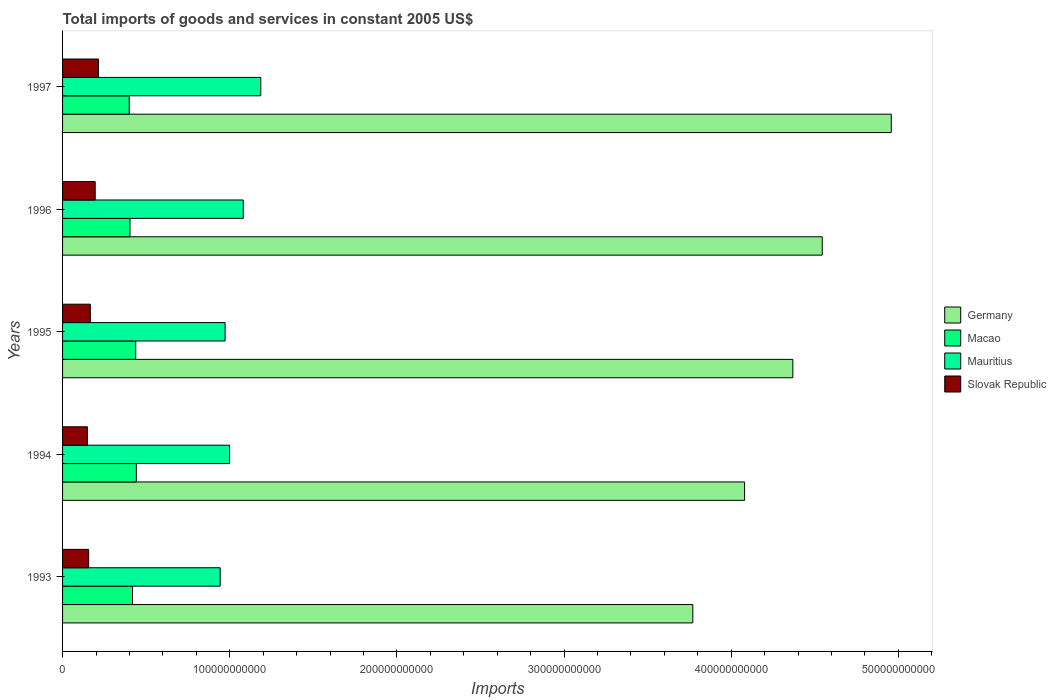How many different coloured bars are there?
Ensure brevity in your answer.  4. Are the number of bars per tick equal to the number of legend labels?
Provide a succinct answer. Yes. Are the number of bars on each tick of the Y-axis equal?
Give a very brief answer. Yes. How many bars are there on the 4th tick from the bottom?
Keep it short and to the point. 4. What is the total imports of goods and services in Germany in 1996?
Your answer should be compact. 4.54e+11. Across all years, what is the maximum total imports of goods and services in Slovak Republic?
Keep it short and to the point. 2.15e+1. Across all years, what is the minimum total imports of goods and services in Slovak Republic?
Offer a terse response. 1.49e+1. In which year was the total imports of goods and services in Mauritius maximum?
Your answer should be very brief. 1997. What is the total total imports of goods and services in Macao in the graph?
Offer a terse response. 2.10e+11. What is the difference between the total imports of goods and services in Slovak Republic in 1994 and that in 1995?
Keep it short and to the point. -1.73e+09. What is the difference between the total imports of goods and services in Macao in 1994 and the total imports of goods and services in Germany in 1997?
Provide a short and direct response. -4.52e+11. What is the average total imports of goods and services in Macao per year?
Ensure brevity in your answer.  4.20e+1. In the year 1994, what is the difference between the total imports of goods and services in Germany and total imports of goods and services in Macao?
Provide a succinct answer. 3.64e+11. In how many years, is the total imports of goods and services in Slovak Republic greater than 320000000000 US$?
Make the answer very short. 0. What is the ratio of the total imports of goods and services in Slovak Republic in 1995 to that in 1996?
Your answer should be very brief. 0.85. What is the difference between the highest and the second highest total imports of goods and services in Mauritius?
Make the answer very short. 1.05e+1. What is the difference between the highest and the lowest total imports of goods and services in Macao?
Keep it short and to the point. 4.26e+09. In how many years, is the total imports of goods and services in Germany greater than the average total imports of goods and services in Germany taken over all years?
Make the answer very short. 3. Is the sum of the total imports of goods and services in Mauritius in 1995 and 1997 greater than the maximum total imports of goods and services in Macao across all years?
Your answer should be very brief. Yes. What does the 2nd bar from the top in 1993 represents?
Keep it short and to the point. Mauritius. What does the 2nd bar from the bottom in 1996 represents?
Offer a very short reply. Macao. Is it the case that in every year, the sum of the total imports of goods and services in Macao and total imports of goods and services in Germany is greater than the total imports of goods and services in Slovak Republic?
Give a very brief answer. Yes. What is the difference between two consecutive major ticks on the X-axis?
Make the answer very short. 1.00e+11. Are the values on the major ticks of X-axis written in scientific E-notation?
Keep it short and to the point. No. Does the graph contain any zero values?
Offer a terse response. No. Where does the legend appear in the graph?
Your answer should be very brief. Center right. How many legend labels are there?
Provide a short and direct response. 4. What is the title of the graph?
Provide a short and direct response. Total imports of goods and services in constant 2005 US$. What is the label or title of the X-axis?
Offer a terse response. Imports. What is the label or title of the Y-axis?
Offer a terse response. Years. What is the Imports of Germany in 1993?
Provide a succinct answer. 3.77e+11. What is the Imports in Macao in 1993?
Ensure brevity in your answer.  4.18e+1. What is the Imports in Mauritius in 1993?
Provide a succinct answer. 9.43e+1. What is the Imports in Slovak Republic in 1993?
Make the answer very short. 1.56e+1. What is the Imports of Germany in 1994?
Your answer should be compact. 4.08e+11. What is the Imports of Macao in 1994?
Your answer should be very brief. 4.41e+1. What is the Imports in Mauritius in 1994?
Your answer should be compact. 9.99e+1. What is the Imports of Slovak Republic in 1994?
Offer a very short reply. 1.49e+1. What is the Imports of Germany in 1995?
Ensure brevity in your answer.  4.37e+11. What is the Imports in Macao in 1995?
Provide a succinct answer. 4.38e+1. What is the Imports in Mauritius in 1995?
Your response must be concise. 9.72e+1. What is the Imports in Slovak Republic in 1995?
Ensure brevity in your answer.  1.66e+1. What is the Imports in Germany in 1996?
Offer a terse response. 4.54e+11. What is the Imports of Macao in 1996?
Your answer should be compact. 4.03e+1. What is the Imports of Mauritius in 1996?
Keep it short and to the point. 1.08e+11. What is the Imports in Slovak Republic in 1996?
Ensure brevity in your answer.  1.95e+1. What is the Imports of Germany in 1997?
Your answer should be very brief. 4.96e+11. What is the Imports of Macao in 1997?
Give a very brief answer. 3.99e+1. What is the Imports of Mauritius in 1997?
Keep it short and to the point. 1.19e+11. What is the Imports in Slovak Republic in 1997?
Your answer should be very brief. 2.15e+1. Across all years, what is the maximum Imports of Germany?
Your response must be concise. 4.96e+11. Across all years, what is the maximum Imports in Macao?
Keep it short and to the point. 4.41e+1. Across all years, what is the maximum Imports of Mauritius?
Provide a succinct answer. 1.19e+11. Across all years, what is the maximum Imports in Slovak Republic?
Provide a succinct answer. 2.15e+1. Across all years, what is the minimum Imports of Germany?
Provide a short and direct response. 3.77e+11. Across all years, what is the minimum Imports of Macao?
Make the answer very short. 3.99e+1. Across all years, what is the minimum Imports of Mauritius?
Keep it short and to the point. 9.43e+1. Across all years, what is the minimum Imports in Slovak Republic?
Your answer should be very brief. 1.49e+1. What is the total Imports in Germany in the graph?
Keep it short and to the point. 2.17e+12. What is the total Imports in Macao in the graph?
Make the answer very short. 2.10e+11. What is the total Imports of Mauritius in the graph?
Ensure brevity in your answer.  5.18e+11. What is the total Imports of Slovak Republic in the graph?
Your answer should be very brief. 8.81e+1. What is the difference between the Imports in Germany in 1993 and that in 1994?
Offer a terse response. -3.10e+1. What is the difference between the Imports of Macao in 1993 and that in 1994?
Make the answer very short. -2.30e+09. What is the difference between the Imports in Mauritius in 1993 and that in 1994?
Give a very brief answer. -5.61e+09. What is the difference between the Imports in Slovak Republic in 1993 and that in 1994?
Offer a terse response. 7.39e+08. What is the difference between the Imports in Germany in 1993 and that in 1995?
Keep it short and to the point. -5.98e+1. What is the difference between the Imports in Macao in 1993 and that in 1995?
Your answer should be very brief. -1.95e+09. What is the difference between the Imports in Mauritius in 1993 and that in 1995?
Offer a very short reply. -2.93e+09. What is the difference between the Imports in Slovak Republic in 1993 and that in 1995?
Give a very brief answer. -9.92e+08. What is the difference between the Imports in Germany in 1993 and that in 1996?
Your answer should be compact. -7.74e+1. What is the difference between the Imports in Macao in 1993 and that in 1996?
Offer a very short reply. 1.51e+09. What is the difference between the Imports of Mauritius in 1993 and that in 1996?
Offer a terse response. -1.38e+1. What is the difference between the Imports in Slovak Republic in 1993 and that in 1996?
Your response must be concise. -3.91e+09. What is the difference between the Imports in Germany in 1993 and that in 1997?
Your answer should be very brief. -1.19e+11. What is the difference between the Imports of Macao in 1993 and that in 1997?
Give a very brief answer. 1.95e+09. What is the difference between the Imports in Mauritius in 1993 and that in 1997?
Provide a succinct answer. -2.43e+1. What is the difference between the Imports of Slovak Republic in 1993 and that in 1997?
Your answer should be very brief. -5.89e+09. What is the difference between the Imports of Germany in 1994 and that in 1995?
Provide a short and direct response. -2.89e+1. What is the difference between the Imports of Macao in 1994 and that in 1995?
Provide a short and direct response. 3.53e+08. What is the difference between the Imports of Mauritius in 1994 and that in 1995?
Keep it short and to the point. 2.69e+09. What is the difference between the Imports in Slovak Republic in 1994 and that in 1995?
Your answer should be compact. -1.73e+09. What is the difference between the Imports of Germany in 1994 and that in 1996?
Your answer should be very brief. -4.65e+1. What is the difference between the Imports of Macao in 1994 and that in 1996?
Offer a terse response. 3.81e+09. What is the difference between the Imports of Mauritius in 1994 and that in 1996?
Provide a short and direct response. -8.19e+09. What is the difference between the Imports in Slovak Republic in 1994 and that in 1996?
Your answer should be compact. -4.65e+09. What is the difference between the Imports in Germany in 1994 and that in 1997?
Your response must be concise. -8.78e+1. What is the difference between the Imports of Macao in 1994 and that in 1997?
Your response must be concise. 4.26e+09. What is the difference between the Imports in Mauritius in 1994 and that in 1997?
Your answer should be very brief. -1.87e+1. What is the difference between the Imports of Slovak Republic in 1994 and that in 1997?
Keep it short and to the point. -6.63e+09. What is the difference between the Imports of Germany in 1995 and that in 1996?
Make the answer very short. -1.76e+1. What is the difference between the Imports in Macao in 1995 and that in 1996?
Your answer should be very brief. 3.46e+09. What is the difference between the Imports in Mauritius in 1995 and that in 1996?
Offer a very short reply. -1.09e+1. What is the difference between the Imports of Slovak Republic in 1995 and that in 1996?
Provide a short and direct response. -2.92e+09. What is the difference between the Imports in Germany in 1995 and that in 1997?
Your answer should be very brief. -5.89e+1. What is the difference between the Imports in Macao in 1995 and that in 1997?
Ensure brevity in your answer.  3.90e+09. What is the difference between the Imports in Mauritius in 1995 and that in 1997?
Your answer should be very brief. -2.14e+1. What is the difference between the Imports in Slovak Republic in 1995 and that in 1997?
Offer a very short reply. -4.90e+09. What is the difference between the Imports of Germany in 1996 and that in 1997?
Give a very brief answer. -4.13e+1. What is the difference between the Imports in Macao in 1996 and that in 1997?
Keep it short and to the point. 4.44e+08. What is the difference between the Imports of Mauritius in 1996 and that in 1997?
Ensure brevity in your answer.  -1.05e+1. What is the difference between the Imports of Slovak Republic in 1996 and that in 1997?
Your answer should be very brief. -1.98e+09. What is the difference between the Imports of Germany in 1993 and the Imports of Macao in 1994?
Keep it short and to the point. 3.33e+11. What is the difference between the Imports of Germany in 1993 and the Imports of Mauritius in 1994?
Your response must be concise. 2.77e+11. What is the difference between the Imports of Germany in 1993 and the Imports of Slovak Republic in 1994?
Your answer should be compact. 3.62e+11. What is the difference between the Imports of Macao in 1993 and the Imports of Mauritius in 1994?
Ensure brevity in your answer.  -5.81e+1. What is the difference between the Imports of Macao in 1993 and the Imports of Slovak Republic in 1994?
Provide a succinct answer. 2.70e+1. What is the difference between the Imports in Mauritius in 1993 and the Imports in Slovak Republic in 1994?
Keep it short and to the point. 7.94e+1. What is the difference between the Imports of Germany in 1993 and the Imports of Macao in 1995?
Offer a very short reply. 3.33e+11. What is the difference between the Imports of Germany in 1993 and the Imports of Mauritius in 1995?
Your answer should be very brief. 2.80e+11. What is the difference between the Imports of Germany in 1993 and the Imports of Slovak Republic in 1995?
Ensure brevity in your answer.  3.60e+11. What is the difference between the Imports of Macao in 1993 and the Imports of Mauritius in 1995?
Give a very brief answer. -5.54e+1. What is the difference between the Imports in Macao in 1993 and the Imports in Slovak Republic in 1995?
Provide a short and direct response. 2.52e+1. What is the difference between the Imports of Mauritius in 1993 and the Imports of Slovak Republic in 1995?
Your answer should be very brief. 7.77e+1. What is the difference between the Imports in Germany in 1993 and the Imports in Macao in 1996?
Ensure brevity in your answer.  3.37e+11. What is the difference between the Imports of Germany in 1993 and the Imports of Mauritius in 1996?
Provide a succinct answer. 2.69e+11. What is the difference between the Imports in Germany in 1993 and the Imports in Slovak Republic in 1996?
Ensure brevity in your answer.  3.58e+11. What is the difference between the Imports in Macao in 1993 and the Imports in Mauritius in 1996?
Offer a terse response. -6.63e+1. What is the difference between the Imports of Macao in 1993 and the Imports of Slovak Republic in 1996?
Your answer should be compact. 2.23e+1. What is the difference between the Imports of Mauritius in 1993 and the Imports of Slovak Republic in 1996?
Provide a succinct answer. 7.48e+1. What is the difference between the Imports in Germany in 1993 and the Imports in Macao in 1997?
Give a very brief answer. 3.37e+11. What is the difference between the Imports in Germany in 1993 and the Imports in Mauritius in 1997?
Your answer should be very brief. 2.58e+11. What is the difference between the Imports in Germany in 1993 and the Imports in Slovak Republic in 1997?
Give a very brief answer. 3.56e+11. What is the difference between the Imports of Macao in 1993 and the Imports of Mauritius in 1997?
Give a very brief answer. -7.68e+1. What is the difference between the Imports in Macao in 1993 and the Imports in Slovak Republic in 1997?
Make the answer very short. 2.03e+1. What is the difference between the Imports in Mauritius in 1993 and the Imports in Slovak Republic in 1997?
Your answer should be very brief. 7.28e+1. What is the difference between the Imports of Germany in 1994 and the Imports of Macao in 1995?
Provide a succinct answer. 3.64e+11. What is the difference between the Imports in Germany in 1994 and the Imports in Mauritius in 1995?
Ensure brevity in your answer.  3.11e+11. What is the difference between the Imports in Germany in 1994 and the Imports in Slovak Republic in 1995?
Offer a very short reply. 3.91e+11. What is the difference between the Imports in Macao in 1994 and the Imports in Mauritius in 1995?
Ensure brevity in your answer.  -5.31e+1. What is the difference between the Imports in Macao in 1994 and the Imports in Slovak Republic in 1995?
Offer a very short reply. 2.75e+1. What is the difference between the Imports of Mauritius in 1994 and the Imports of Slovak Republic in 1995?
Provide a short and direct response. 8.33e+1. What is the difference between the Imports in Germany in 1994 and the Imports in Macao in 1996?
Offer a very short reply. 3.68e+11. What is the difference between the Imports in Germany in 1994 and the Imports in Mauritius in 1996?
Your answer should be very brief. 3.00e+11. What is the difference between the Imports of Germany in 1994 and the Imports of Slovak Republic in 1996?
Your answer should be compact. 3.88e+11. What is the difference between the Imports of Macao in 1994 and the Imports of Mauritius in 1996?
Your response must be concise. -6.40e+1. What is the difference between the Imports of Macao in 1994 and the Imports of Slovak Republic in 1996?
Keep it short and to the point. 2.46e+1. What is the difference between the Imports of Mauritius in 1994 and the Imports of Slovak Republic in 1996?
Your response must be concise. 8.04e+1. What is the difference between the Imports in Germany in 1994 and the Imports in Macao in 1997?
Provide a succinct answer. 3.68e+11. What is the difference between the Imports of Germany in 1994 and the Imports of Mauritius in 1997?
Offer a terse response. 2.89e+11. What is the difference between the Imports of Germany in 1994 and the Imports of Slovak Republic in 1997?
Provide a short and direct response. 3.87e+11. What is the difference between the Imports in Macao in 1994 and the Imports in Mauritius in 1997?
Make the answer very short. -7.45e+1. What is the difference between the Imports of Macao in 1994 and the Imports of Slovak Republic in 1997?
Ensure brevity in your answer.  2.26e+1. What is the difference between the Imports of Mauritius in 1994 and the Imports of Slovak Republic in 1997?
Your answer should be compact. 7.84e+1. What is the difference between the Imports in Germany in 1995 and the Imports in Macao in 1996?
Offer a very short reply. 3.97e+11. What is the difference between the Imports in Germany in 1995 and the Imports in Mauritius in 1996?
Your answer should be compact. 3.29e+11. What is the difference between the Imports in Germany in 1995 and the Imports in Slovak Republic in 1996?
Provide a short and direct response. 4.17e+11. What is the difference between the Imports in Macao in 1995 and the Imports in Mauritius in 1996?
Provide a succinct answer. -6.43e+1. What is the difference between the Imports in Macao in 1995 and the Imports in Slovak Republic in 1996?
Provide a succinct answer. 2.43e+1. What is the difference between the Imports of Mauritius in 1995 and the Imports of Slovak Republic in 1996?
Your answer should be very brief. 7.77e+1. What is the difference between the Imports of Germany in 1995 and the Imports of Macao in 1997?
Make the answer very short. 3.97e+11. What is the difference between the Imports of Germany in 1995 and the Imports of Mauritius in 1997?
Give a very brief answer. 3.18e+11. What is the difference between the Imports of Germany in 1995 and the Imports of Slovak Republic in 1997?
Offer a very short reply. 4.15e+11. What is the difference between the Imports in Macao in 1995 and the Imports in Mauritius in 1997?
Provide a short and direct response. -7.48e+1. What is the difference between the Imports of Macao in 1995 and the Imports of Slovak Republic in 1997?
Your answer should be compact. 2.23e+1. What is the difference between the Imports in Mauritius in 1995 and the Imports in Slovak Republic in 1997?
Give a very brief answer. 7.57e+1. What is the difference between the Imports of Germany in 1996 and the Imports of Macao in 1997?
Provide a short and direct response. 4.15e+11. What is the difference between the Imports of Germany in 1996 and the Imports of Mauritius in 1997?
Offer a terse response. 3.36e+11. What is the difference between the Imports in Germany in 1996 and the Imports in Slovak Republic in 1997?
Your response must be concise. 4.33e+11. What is the difference between the Imports of Macao in 1996 and the Imports of Mauritius in 1997?
Your answer should be compact. -7.83e+1. What is the difference between the Imports in Macao in 1996 and the Imports in Slovak Republic in 1997?
Your answer should be compact. 1.88e+1. What is the difference between the Imports in Mauritius in 1996 and the Imports in Slovak Republic in 1997?
Provide a succinct answer. 8.66e+1. What is the average Imports in Germany per year?
Keep it short and to the point. 4.34e+11. What is the average Imports of Macao per year?
Provide a succinct answer. 4.20e+1. What is the average Imports of Mauritius per year?
Offer a terse response. 1.04e+11. What is the average Imports of Slovak Republic per year?
Offer a very short reply. 1.76e+1. In the year 1993, what is the difference between the Imports in Germany and Imports in Macao?
Your response must be concise. 3.35e+11. In the year 1993, what is the difference between the Imports in Germany and Imports in Mauritius?
Your answer should be compact. 2.83e+11. In the year 1993, what is the difference between the Imports in Germany and Imports in Slovak Republic?
Provide a succinct answer. 3.61e+11. In the year 1993, what is the difference between the Imports in Macao and Imports in Mauritius?
Provide a succinct answer. -5.25e+1. In the year 1993, what is the difference between the Imports in Macao and Imports in Slovak Republic?
Provide a short and direct response. 2.62e+1. In the year 1993, what is the difference between the Imports in Mauritius and Imports in Slovak Republic?
Give a very brief answer. 7.87e+1. In the year 1994, what is the difference between the Imports of Germany and Imports of Macao?
Keep it short and to the point. 3.64e+11. In the year 1994, what is the difference between the Imports of Germany and Imports of Mauritius?
Ensure brevity in your answer.  3.08e+11. In the year 1994, what is the difference between the Imports in Germany and Imports in Slovak Republic?
Provide a short and direct response. 3.93e+11. In the year 1994, what is the difference between the Imports in Macao and Imports in Mauritius?
Keep it short and to the point. -5.58e+1. In the year 1994, what is the difference between the Imports in Macao and Imports in Slovak Republic?
Keep it short and to the point. 2.93e+1. In the year 1994, what is the difference between the Imports in Mauritius and Imports in Slovak Republic?
Make the answer very short. 8.50e+1. In the year 1995, what is the difference between the Imports of Germany and Imports of Macao?
Your answer should be compact. 3.93e+11. In the year 1995, what is the difference between the Imports of Germany and Imports of Mauritius?
Your answer should be very brief. 3.40e+11. In the year 1995, what is the difference between the Imports in Germany and Imports in Slovak Republic?
Provide a succinct answer. 4.20e+11. In the year 1995, what is the difference between the Imports in Macao and Imports in Mauritius?
Offer a very short reply. -5.34e+1. In the year 1995, what is the difference between the Imports of Macao and Imports of Slovak Republic?
Keep it short and to the point. 2.72e+1. In the year 1995, what is the difference between the Imports in Mauritius and Imports in Slovak Republic?
Your answer should be very brief. 8.06e+1. In the year 1996, what is the difference between the Imports of Germany and Imports of Macao?
Keep it short and to the point. 4.14e+11. In the year 1996, what is the difference between the Imports of Germany and Imports of Mauritius?
Provide a succinct answer. 3.46e+11. In the year 1996, what is the difference between the Imports in Germany and Imports in Slovak Republic?
Ensure brevity in your answer.  4.35e+11. In the year 1996, what is the difference between the Imports in Macao and Imports in Mauritius?
Provide a succinct answer. -6.78e+1. In the year 1996, what is the difference between the Imports in Macao and Imports in Slovak Republic?
Offer a very short reply. 2.08e+1. In the year 1996, what is the difference between the Imports of Mauritius and Imports of Slovak Republic?
Make the answer very short. 8.86e+1. In the year 1997, what is the difference between the Imports of Germany and Imports of Macao?
Give a very brief answer. 4.56e+11. In the year 1997, what is the difference between the Imports in Germany and Imports in Mauritius?
Your response must be concise. 3.77e+11. In the year 1997, what is the difference between the Imports in Germany and Imports in Slovak Republic?
Ensure brevity in your answer.  4.74e+11. In the year 1997, what is the difference between the Imports in Macao and Imports in Mauritius?
Offer a very short reply. -7.87e+1. In the year 1997, what is the difference between the Imports in Macao and Imports in Slovak Republic?
Your response must be concise. 1.84e+1. In the year 1997, what is the difference between the Imports of Mauritius and Imports of Slovak Republic?
Offer a terse response. 9.71e+1. What is the ratio of the Imports of Germany in 1993 to that in 1994?
Ensure brevity in your answer.  0.92. What is the ratio of the Imports in Macao in 1993 to that in 1994?
Your response must be concise. 0.95. What is the ratio of the Imports in Mauritius in 1993 to that in 1994?
Keep it short and to the point. 0.94. What is the ratio of the Imports in Slovak Republic in 1993 to that in 1994?
Ensure brevity in your answer.  1.05. What is the ratio of the Imports in Germany in 1993 to that in 1995?
Provide a short and direct response. 0.86. What is the ratio of the Imports of Macao in 1993 to that in 1995?
Offer a very short reply. 0.96. What is the ratio of the Imports in Mauritius in 1993 to that in 1995?
Offer a terse response. 0.97. What is the ratio of the Imports in Slovak Republic in 1993 to that in 1995?
Provide a succinct answer. 0.94. What is the ratio of the Imports of Germany in 1993 to that in 1996?
Give a very brief answer. 0.83. What is the ratio of the Imports in Macao in 1993 to that in 1996?
Give a very brief answer. 1.04. What is the ratio of the Imports of Mauritius in 1993 to that in 1996?
Provide a succinct answer. 0.87. What is the ratio of the Imports of Slovak Republic in 1993 to that in 1996?
Provide a succinct answer. 0.8. What is the ratio of the Imports of Germany in 1993 to that in 1997?
Your answer should be compact. 0.76. What is the ratio of the Imports of Macao in 1993 to that in 1997?
Ensure brevity in your answer.  1.05. What is the ratio of the Imports of Mauritius in 1993 to that in 1997?
Offer a very short reply. 0.8. What is the ratio of the Imports of Slovak Republic in 1993 to that in 1997?
Your answer should be very brief. 0.73. What is the ratio of the Imports of Germany in 1994 to that in 1995?
Give a very brief answer. 0.93. What is the ratio of the Imports of Macao in 1994 to that in 1995?
Offer a very short reply. 1.01. What is the ratio of the Imports in Mauritius in 1994 to that in 1995?
Your response must be concise. 1.03. What is the ratio of the Imports of Slovak Republic in 1994 to that in 1995?
Give a very brief answer. 0.9. What is the ratio of the Imports of Germany in 1994 to that in 1996?
Make the answer very short. 0.9. What is the ratio of the Imports of Macao in 1994 to that in 1996?
Offer a very short reply. 1.09. What is the ratio of the Imports in Mauritius in 1994 to that in 1996?
Keep it short and to the point. 0.92. What is the ratio of the Imports in Slovak Republic in 1994 to that in 1996?
Provide a short and direct response. 0.76. What is the ratio of the Imports of Germany in 1994 to that in 1997?
Provide a short and direct response. 0.82. What is the ratio of the Imports in Macao in 1994 to that in 1997?
Provide a succinct answer. 1.11. What is the ratio of the Imports in Mauritius in 1994 to that in 1997?
Make the answer very short. 0.84. What is the ratio of the Imports of Slovak Republic in 1994 to that in 1997?
Offer a terse response. 0.69. What is the ratio of the Imports in Germany in 1995 to that in 1996?
Your answer should be compact. 0.96. What is the ratio of the Imports in Macao in 1995 to that in 1996?
Provide a short and direct response. 1.09. What is the ratio of the Imports of Mauritius in 1995 to that in 1996?
Ensure brevity in your answer.  0.9. What is the ratio of the Imports in Slovak Republic in 1995 to that in 1996?
Offer a very short reply. 0.85. What is the ratio of the Imports in Germany in 1995 to that in 1997?
Provide a succinct answer. 0.88. What is the ratio of the Imports in Macao in 1995 to that in 1997?
Give a very brief answer. 1.1. What is the ratio of the Imports in Mauritius in 1995 to that in 1997?
Your answer should be compact. 0.82. What is the ratio of the Imports of Slovak Republic in 1995 to that in 1997?
Give a very brief answer. 0.77. What is the ratio of the Imports in Germany in 1996 to that in 1997?
Offer a terse response. 0.92. What is the ratio of the Imports in Macao in 1996 to that in 1997?
Give a very brief answer. 1.01. What is the ratio of the Imports in Mauritius in 1996 to that in 1997?
Your answer should be very brief. 0.91. What is the ratio of the Imports in Slovak Republic in 1996 to that in 1997?
Your answer should be very brief. 0.91. What is the difference between the highest and the second highest Imports of Germany?
Your answer should be compact. 4.13e+1. What is the difference between the highest and the second highest Imports in Macao?
Provide a succinct answer. 3.53e+08. What is the difference between the highest and the second highest Imports in Mauritius?
Your answer should be compact. 1.05e+1. What is the difference between the highest and the second highest Imports in Slovak Republic?
Your response must be concise. 1.98e+09. What is the difference between the highest and the lowest Imports of Germany?
Provide a short and direct response. 1.19e+11. What is the difference between the highest and the lowest Imports of Macao?
Provide a short and direct response. 4.26e+09. What is the difference between the highest and the lowest Imports in Mauritius?
Your answer should be compact. 2.43e+1. What is the difference between the highest and the lowest Imports in Slovak Republic?
Your answer should be very brief. 6.63e+09. 